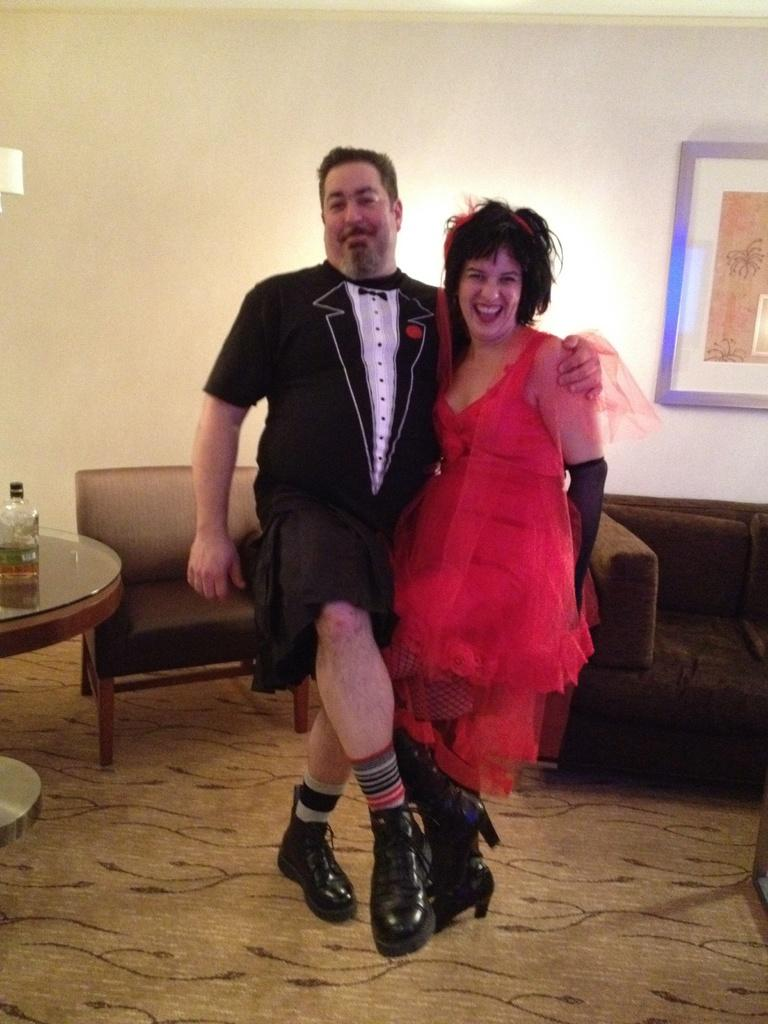What type of structure can be seen in the image? There is a wall in the image. What is hanging on the wall? There is a photo frame in the image. What type of furniture is present in the image? There are sofas and a table in the image. How many people are in the image? There are two people standing in the image. What is on the table? There is a bottle on the table. What type of wound can be seen on the person's stomach in the image? There is no wound visible on anyone's stomach in the image. What type of apparel is the person wearing in the image? The provided facts do not mention any specific apparel worn by the people in the image. 